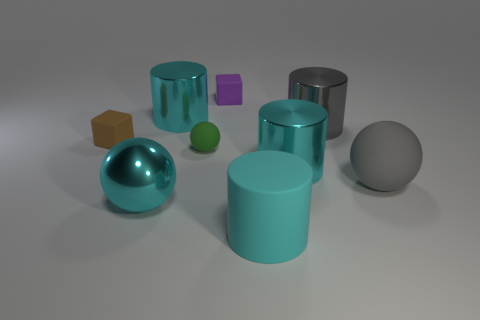Subtract all gray cylinders. How many cylinders are left? 3 Subtract all spheres. How many objects are left? 6 Subtract all gray cylinders. How many cylinders are left? 3 Subtract 1 cylinders. How many cylinders are left? 3 Add 1 large cyan shiny cylinders. How many objects exist? 10 Subtract all red spheres. How many cyan cylinders are left? 3 Subtract 1 brown cubes. How many objects are left? 8 Subtract all gray cylinders. Subtract all yellow spheres. How many cylinders are left? 3 Subtract all small red things. Subtract all large gray metal cylinders. How many objects are left? 8 Add 2 large cyan objects. How many large cyan objects are left? 6 